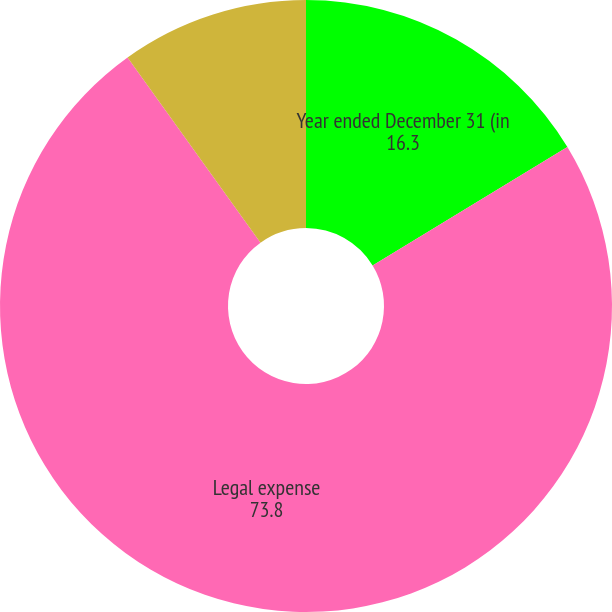Convert chart. <chart><loc_0><loc_0><loc_500><loc_500><pie_chart><fcel>Year ended December 31 (in<fcel>Legal expense<fcel>Federal Deposit Insurance<nl><fcel>16.3%<fcel>73.8%<fcel>9.91%<nl></chart> 